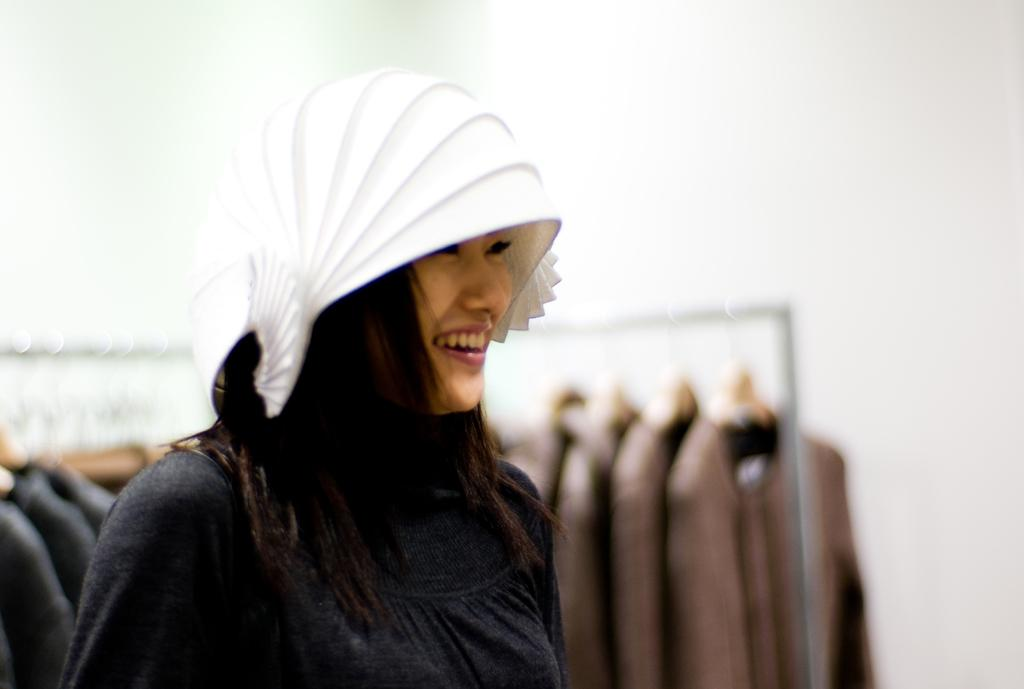What is the main subject of the image? There is a woman standing in the image. What is the woman wearing on her head? The woman is wearing a black color cap. What can be seen hanging in the image? Clothes are hanging from hangers in the image. What is visible in the background of the image? There is a wall in the background of the image. How many trees can be seen behind the woman in the image? There are no trees visible in the image; it only shows a wall in the background. What type of sock is the woman wearing in the image? The image does not show the woman's socks, so it cannot be determined what type of sock she is wearing. 